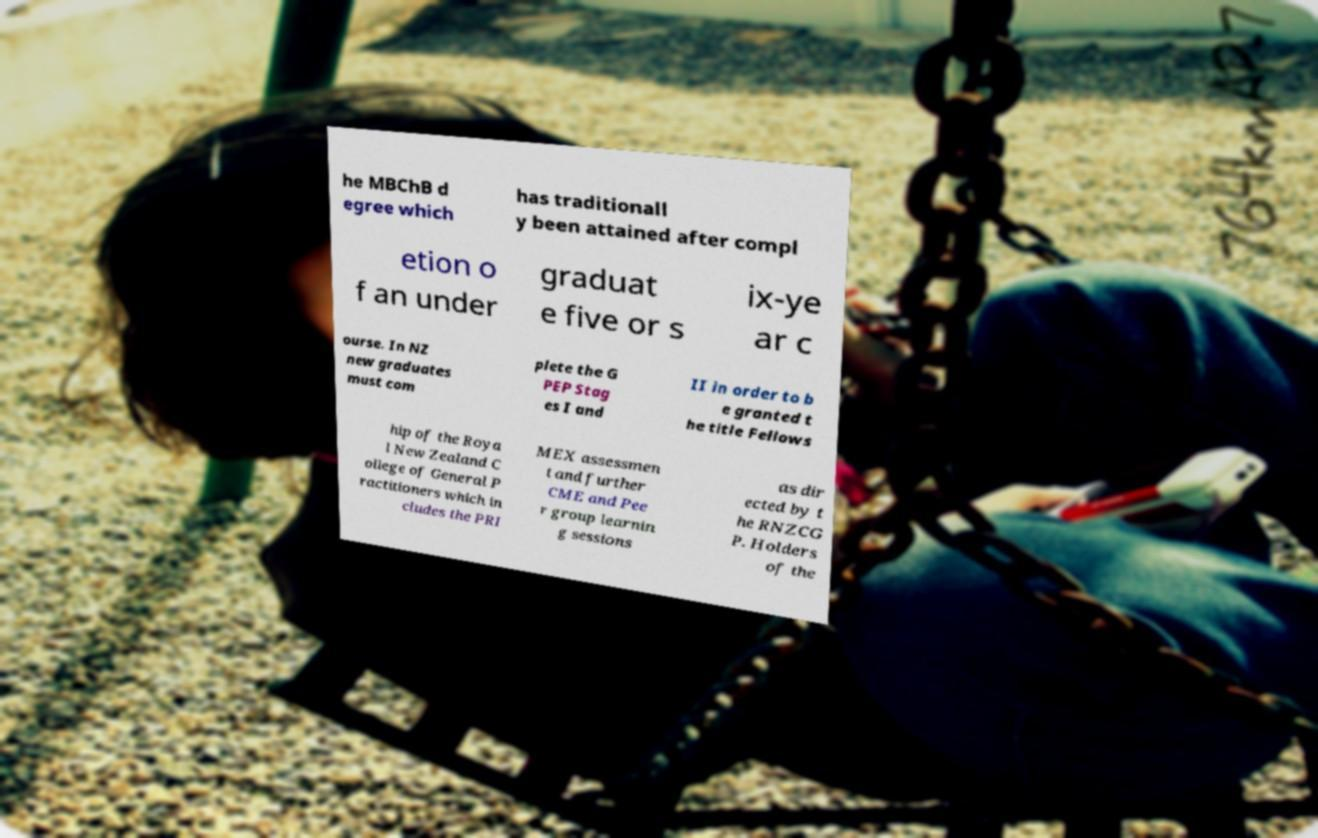Can you read and provide the text displayed in the image?This photo seems to have some interesting text. Can you extract and type it out for me? he MBChB d egree which has traditionall y been attained after compl etion o f an under graduat e five or s ix-ye ar c ourse. In NZ new graduates must com plete the G PEP Stag es I and II in order to b e granted t he title Fellows hip of the Roya l New Zealand C ollege of General P ractitioners which in cludes the PRI MEX assessmen t and further CME and Pee r group learnin g sessions as dir ected by t he RNZCG P. Holders of the 